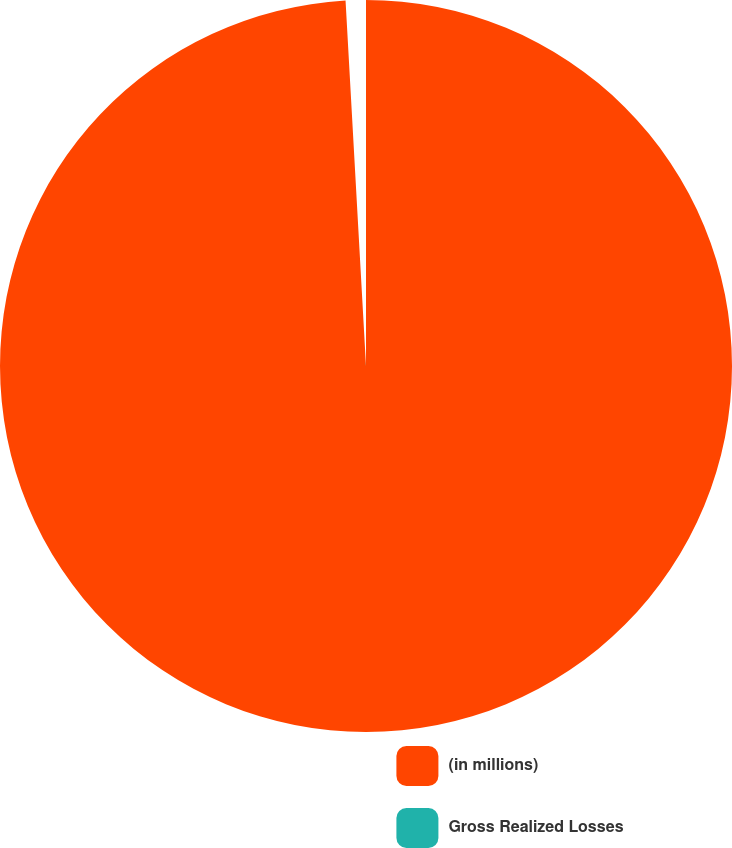Convert chart. <chart><loc_0><loc_0><loc_500><loc_500><pie_chart><fcel>(in millions)<fcel>Gross Realized Losses<nl><fcel>99.11%<fcel>0.89%<nl></chart> 